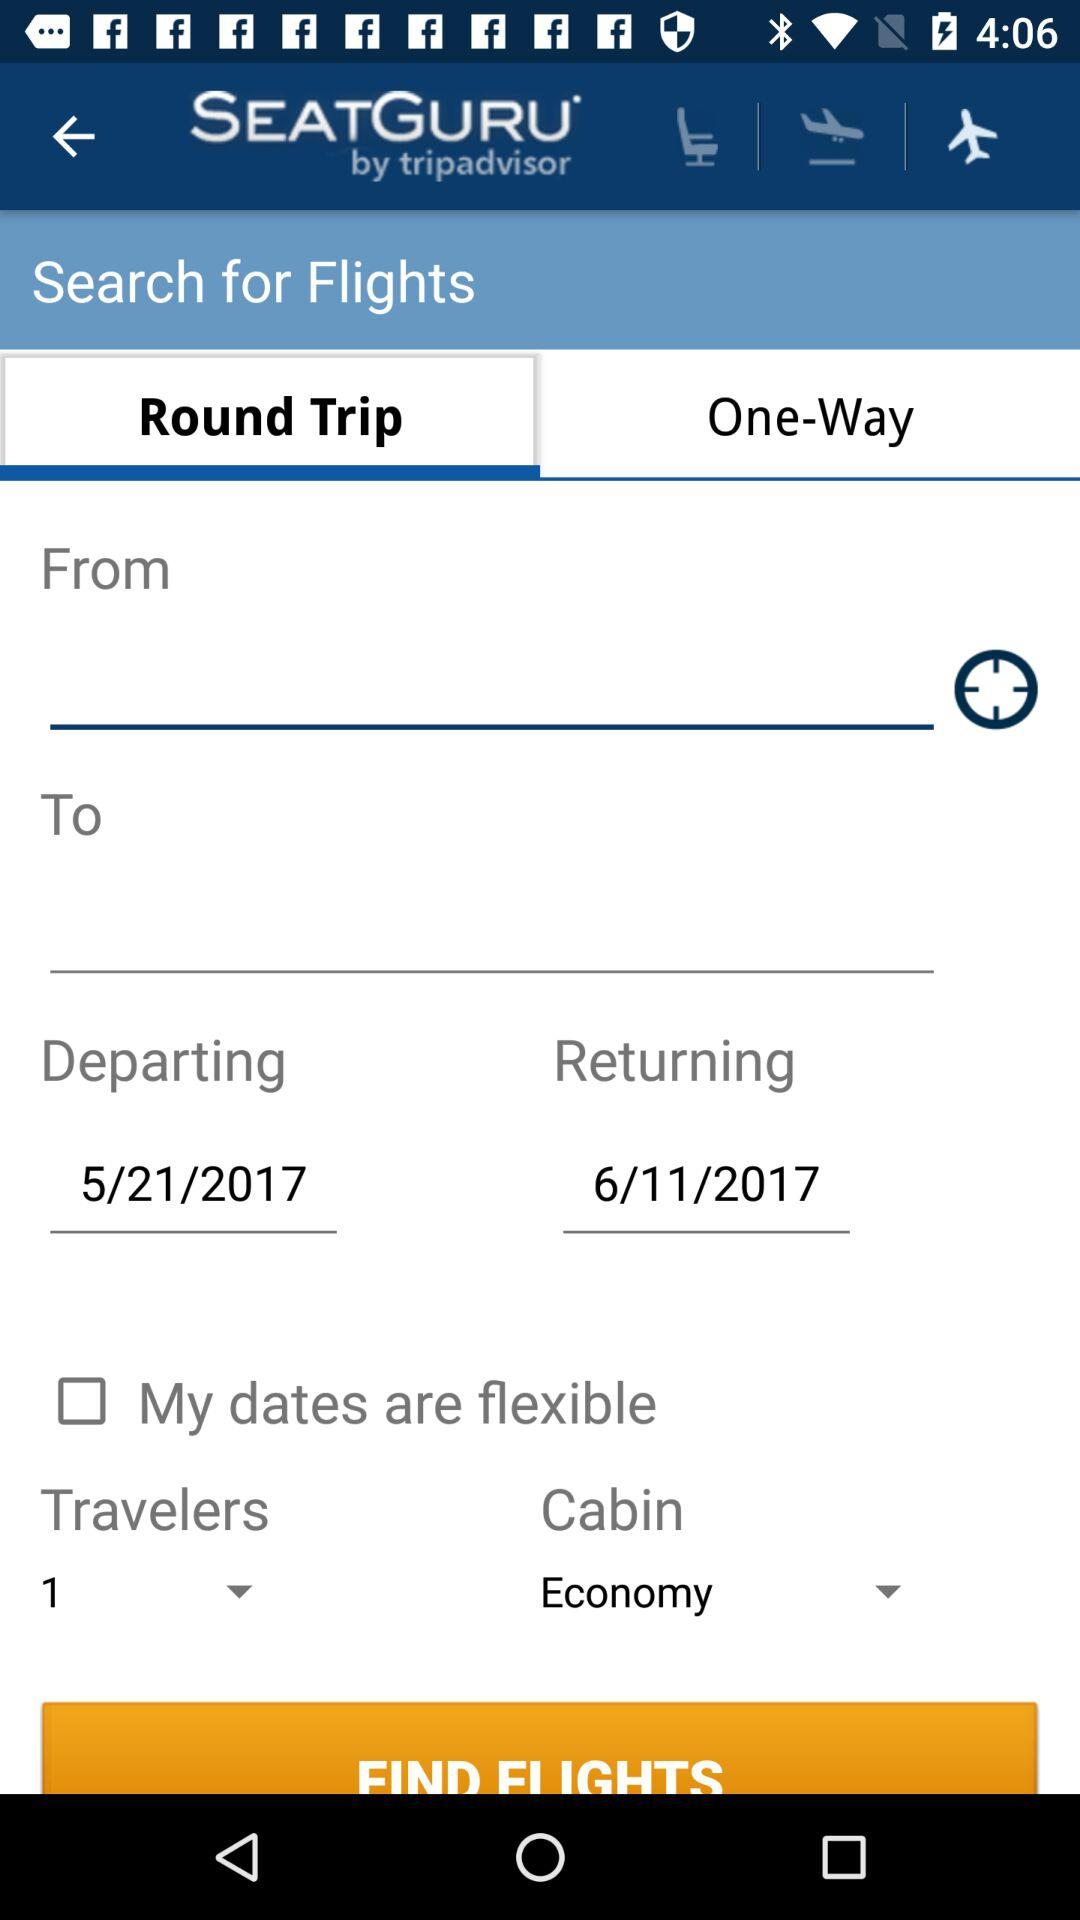What type of cabin is it? The type of cabin is "Economy". 